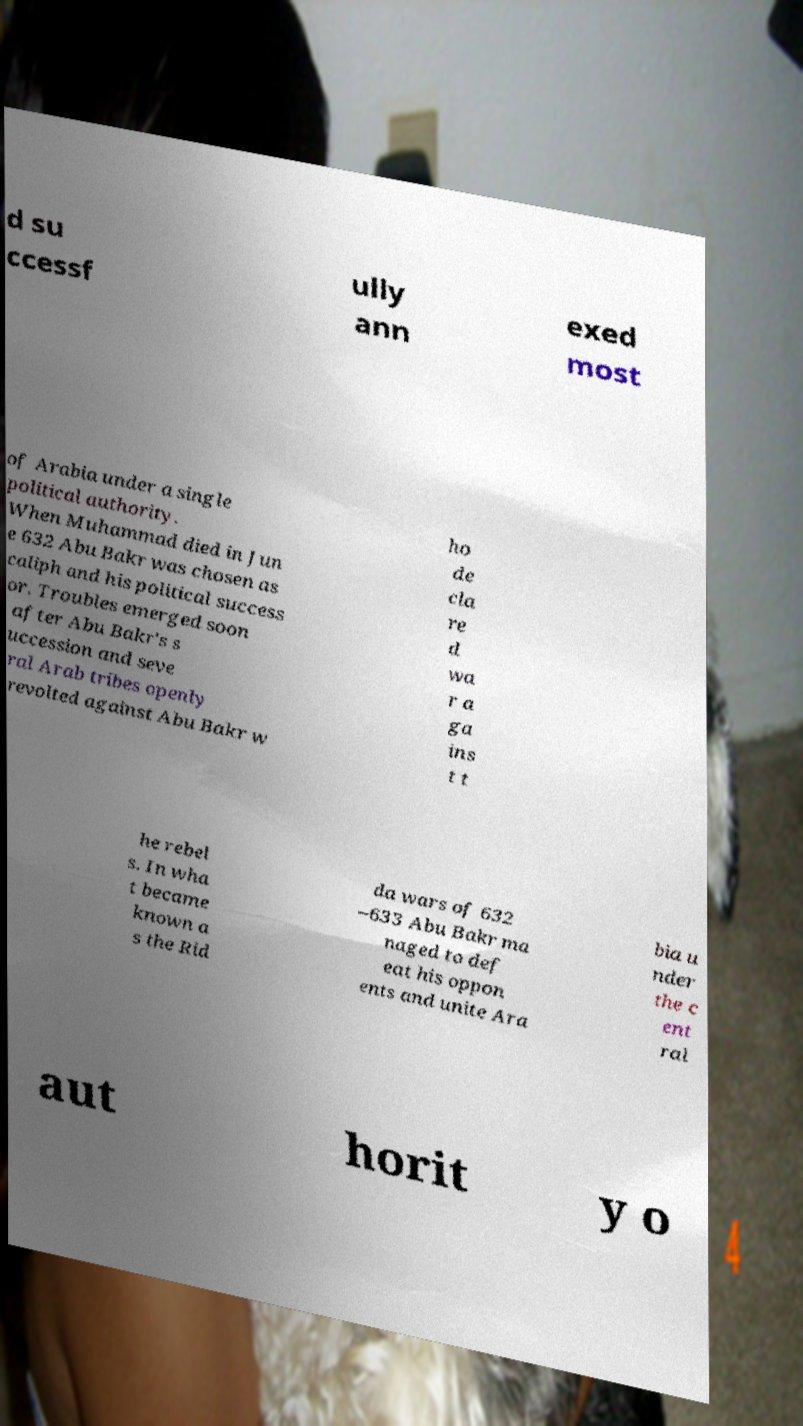I need the written content from this picture converted into text. Can you do that? d su ccessf ully ann exed most of Arabia under a single political authority. When Muhammad died in Jun e 632 Abu Bakr was chosen as caliph and his political success or. Troubles emerged soon after Abu Bakr's s uccession and seve ral Arab tribes openly revolted against Abu Bakr w ho de cla re d wa r a ga ins t t he rebel s. In wha t became known a s the Rid da wars of 632 –633 Abu Bakr ma naged to def eat his oppon ents and unite Ara bia u nder the c ent ral aut horit y o 